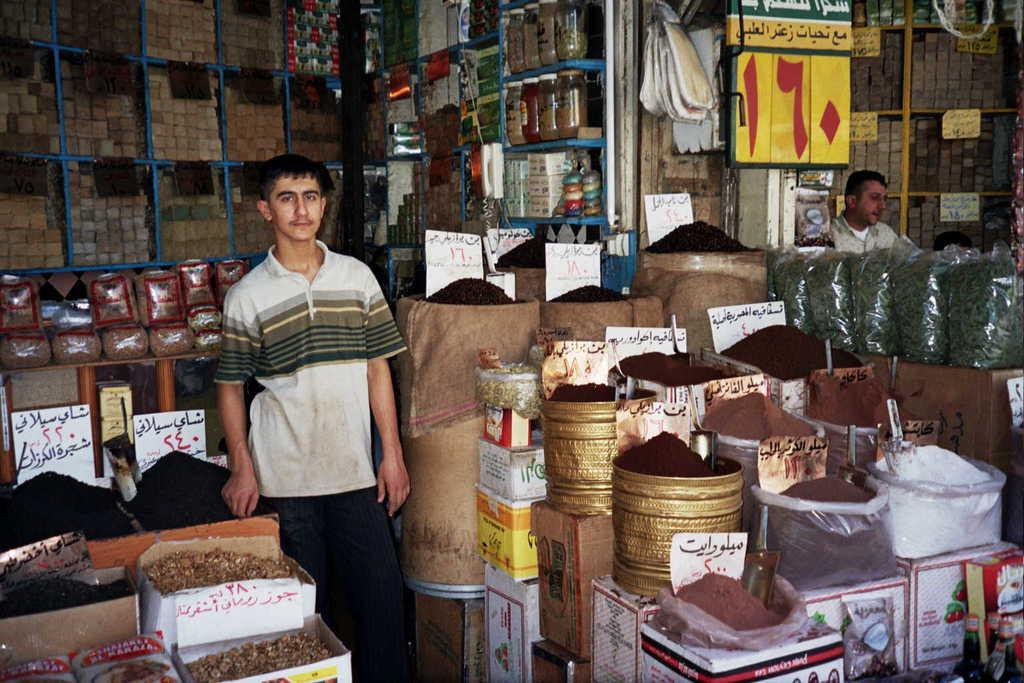How would you summarize this image in a sentence or two? In this picture I can see there is a man standing in the shop and there are many powders and boxes placed here. On right side there is another man sitting. 